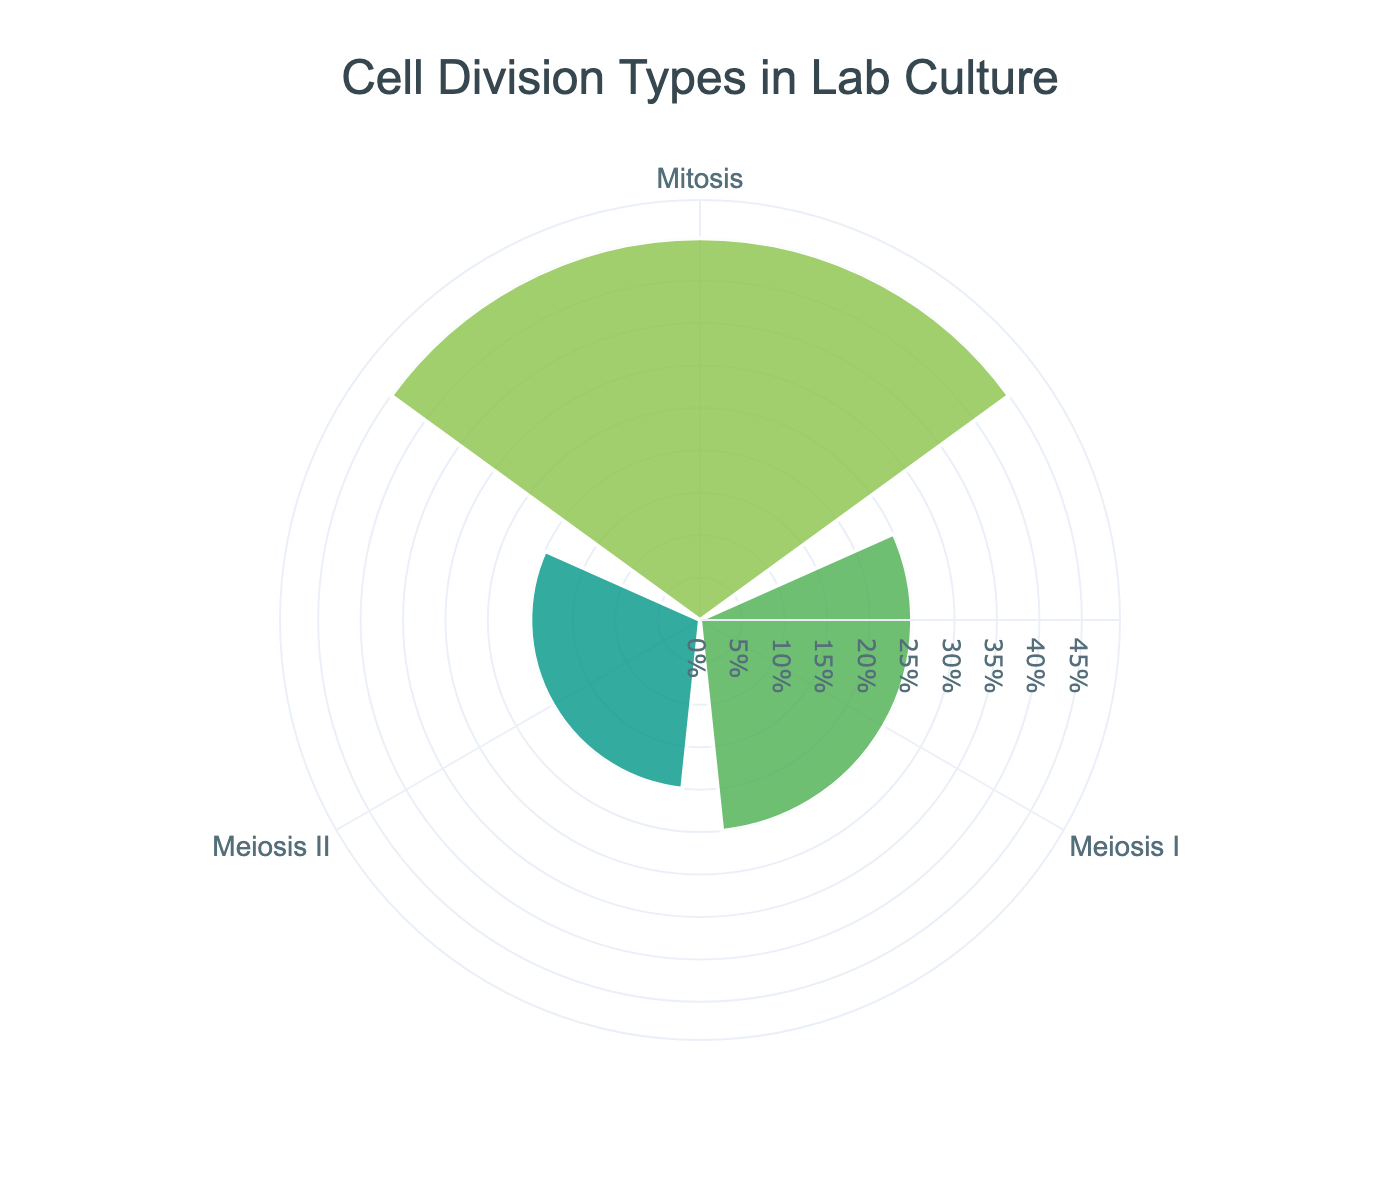what is the title of the figure? The title is displayed at the top of the rose chart. It is centered and formatted in a large font.
Answer: Cell Division Types in Lab Culture What are the three cell division types shown in the rose chart? The figure shows the top three cell division types based on their proportions, which are displayed as segments on the rose chart.
Answer: Mitosis, Meiosis I, Meiosis II Which cell division type has the highest proportion? By observing the lengths of the radial bars, the longest bar corresponds to the cell division type with the highest proportion.
Answer: Mitosis What is the combined proportion of Meiosis I and Meiosis II? To find this, add the proportion of Meiosis I and Meiosis II as displayed on the chart. The proportions are labeled next to the respective segments.
Answer: 45% What is the smallest proportion among the three displayed cell division types? By comparing the lengths of the radial bars, the shortest bar represents the smallest proportion.
Answer: Meiosis II How does the proportion of Mitosis compare to that of Meiosis I? Compare the lengths of the radial bars for Mitosis and Meiosis I. The length of the bar indicates the proportion.
Answer: Mitosis has a higher proportion than Meiosis I What is the difference in percentage points between the highest and lowest proportions? Subtract the lowest proportion from the highest proportion based on the values shown in the chart.
Answer: 25 percentage points If the sum of all cell division types shown is considered as 100%, what can you infer about the remaining proportion allocated to Amitosis? The rose chart shows only the top three cell division types. Since they add up to 90%, the remaining proportion out of 100% must be for Amitosis.
Answer: 10% What is the total proportion of the top two most common cell division types? Add the proportions of the two cell division types with the longest radial bars.
Answer: 70% How are the radial axis labels customized in the rose chart? The radial axis labels are customized to show percentage values, with tick marks and font styling for clarity. This is evident from the radial lines extending outward with percentage markers.
Answer: They show percentage values with tick marks and custom fonts 